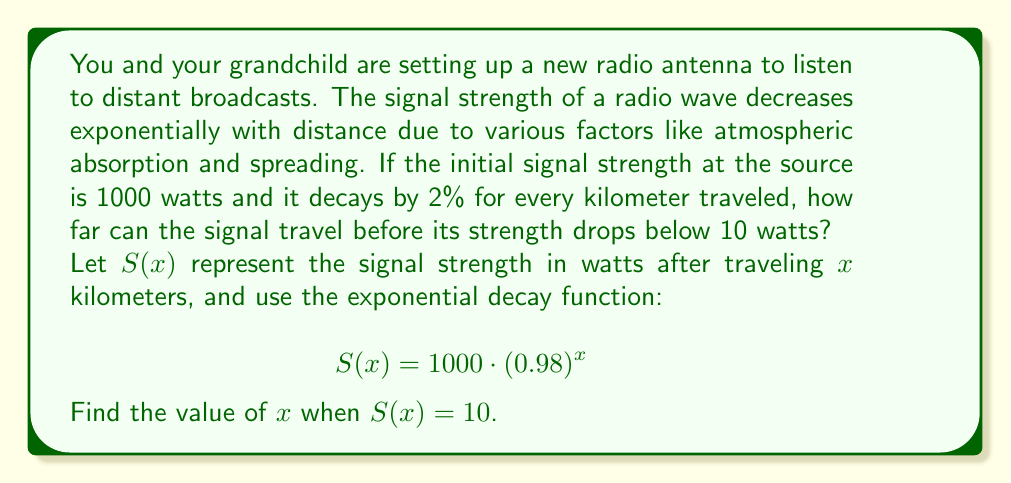Show me your answer to this math problem. To solve this problem, we'll use the exponential decay function and solve for $x$:

1) We start with the given equation:
   $$S(x) = 1000 \cdot (0.98)^x$$

2) We want to find $x$ when $S(x) = 10$, so we substitute this:
   $$10 = 1000 \cdot (0.98)^x$$

3) Divide both sides by 1000:
   $$\frac{10}{1000} = (0.98)^x$$
   $$0.01 = (0.98)^x$$

4) Now, we need to solve for $x$. We can do this by taking the natural logarithm of both sides:
   $$\ln(0.01) = \ln((0.98)^x)$$

5) Using the logarithm property $\ln(a^b) = b\ln(a)$:
   $$\ln(0.01) = x \cdot \ln(0.98)$$

6) Solve for $x$ by dividing both sides by $\ln(0.98)$:
   $$x = \frac{\ln(0.01)}{\ln(0.98)}$$

7) Use a calculator to evaluate this:
   $$x \approx 228.16$$

Therefore, the signal can travel approximately 228.16 kilometers before its strength drops below 10 watts.
Answer: The signal can travel approximately 228.16 kilometers before its strength drops below 10 watts. 